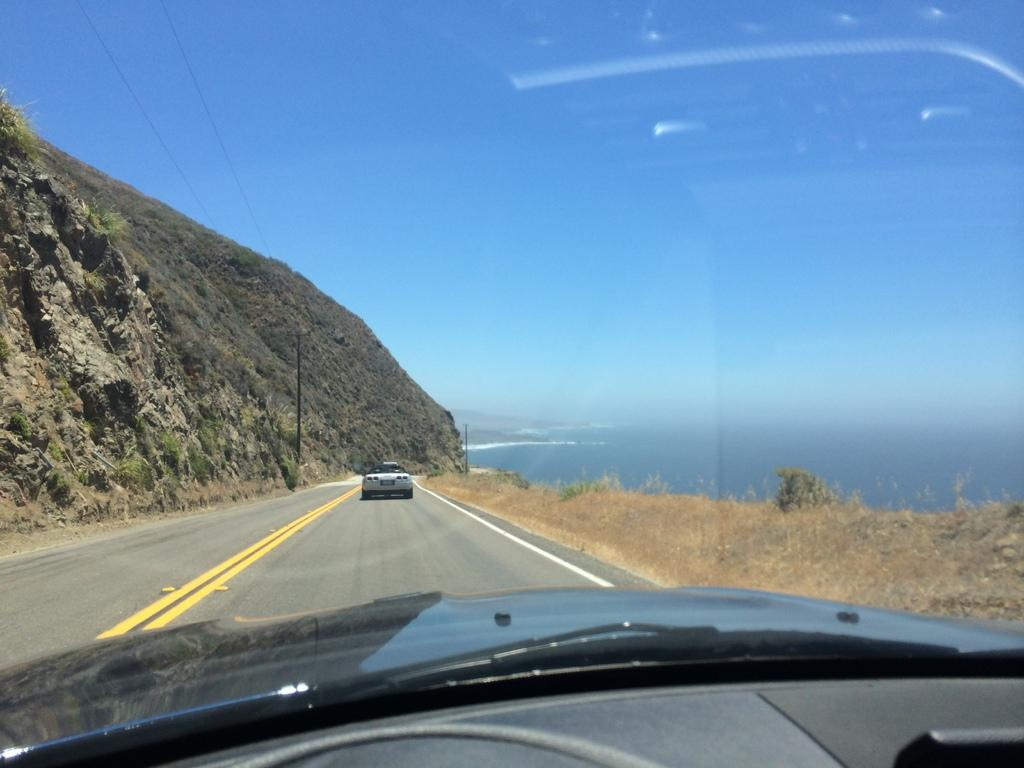What types of vehicles can be seen in the image? There are vehicles in the image, but the specific types are not mentioned. What natural features are present in the image? There are mountains and water visible in the image. What is the condition of the grass in the image? Dry grass is present in the image. What is the color of the sky in the image? The sky is blue and white in color. Can you tell me how many crackers are floating in the water in the image? There are no crackers present in the image; it features vehicles, mountains, water, dry grass, and a blue and white sky. What type of operation is being performed on the mountains in the image? There is no operation being performed on the mountains in the image; they are simply visible in the background. 